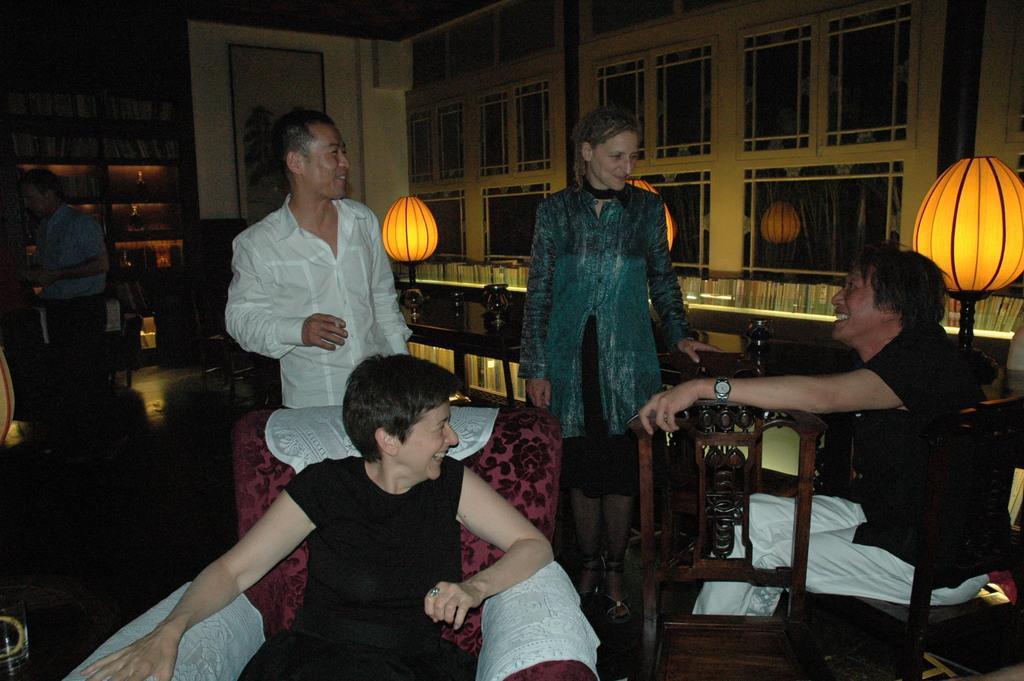In one or two sentences, can you explain what this image depicts? In this image we can see two persons sitting on chairs. Three persons are standing. There are lights on stands. In the back there is a cupboard with books. Also there is a frame with painting on the wall. On the right side there are books on the cupboard. Also there are glass panes. In the left bottom corner there is a glass on a surface. 